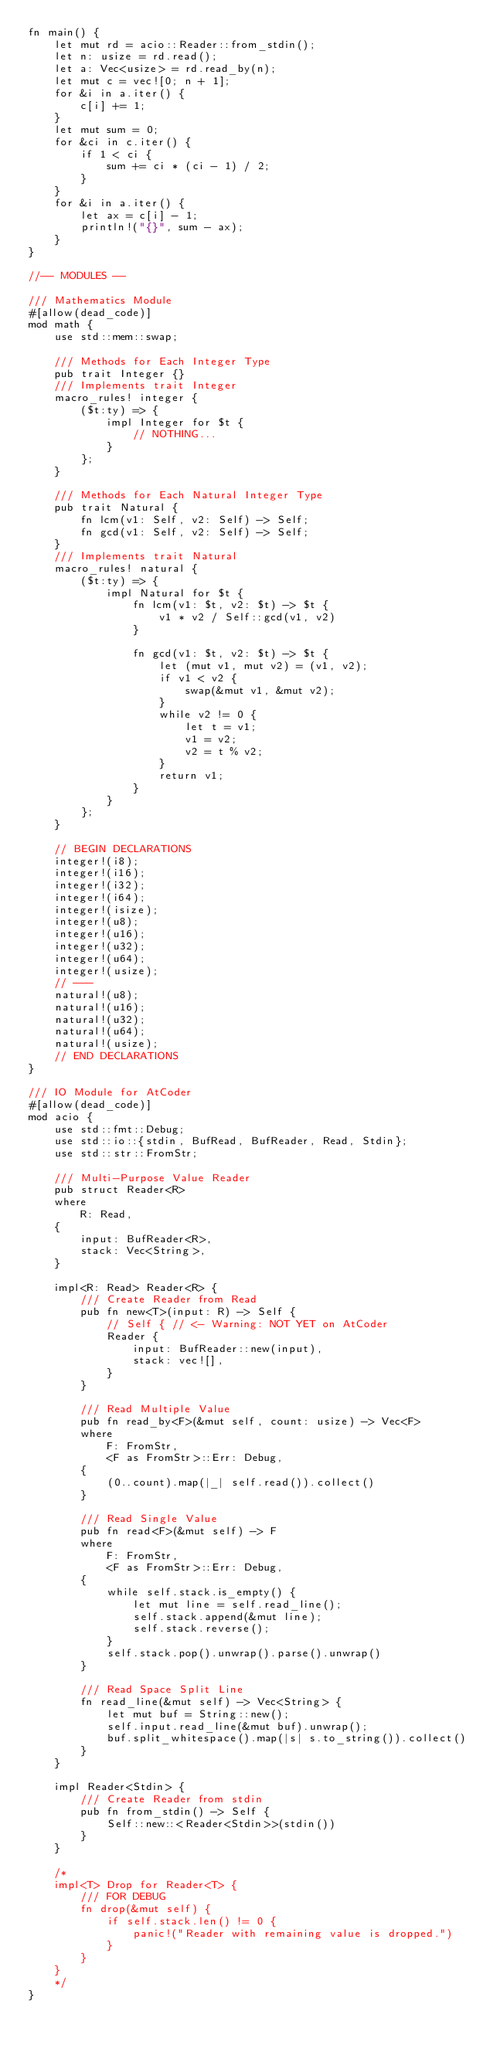<code> <loc_0><loc_0><loc_500><loc_500><_Rust_>fn main() {
    let mut rd = acio::Reader::from_stdin();
    let n: usize = rd.read();
    let a: Vec<usize> = rd.read_by(n);
    let mut c = vec![0; n + 1];
    for &i in a.iter() {
        c[i] += 1;
    }
    let mut sum = 0;
    for &ci in c.iter() {
        if 1 < ci {
            sum += ci * (ci - 1) / 2;
        }
    }
    for &i in a.iter() {
        let ax = c[i] - 1;
        println!("{}", sum - ax);
    }
}

//-- MODULES --

/// Mathematics Module
#[allow(dead_code)]
mod math {
    use std::mem::swap;

    /// Methods for Each Integer Type
    pub trait Integer {}
    /// Implements trait Integer
    macro_rules! integer {
        ($t:ty) => {
            impl Integer for $t {
                // NOTHING...
            }
        };
    }

    /// Methods for Each Natural Integer Type
    pub trait Natural {
        fn lcm(v1: Self, v2: Self) -> Self;
        fn gcd(v1: Self, v2: Self) -> Self;
    }
    /// Implements trait Natural
    macro_rules! natural {
        ($t:ty) => {
            impl Natural for $t {
                fn lcm(v1: $t, v2: $t) -> $t {
                    v1 * v2 / Self::gcd(v1, v2)
                }

                fn gcd(v1: $t, v2: $t) -> $t {
                    let (mut v1, mut v2) = (v1, v2);
                    if v1 < v2 {
                        swap(&mut v1, &mut v2);
                    }
                    while v2 != 0 {
                        let t = v1;
                        v1 = v2;
                        v2 = t % v2;
                    }
                    return v1;
                }
            }
        };
    }

    // BEGIN DECLARATIONS
    integer!(i8);
    integer!(i16);
    integer!(i32);
    integer!(i64);
    integer!(isize);
    integer!(u8);
    integer!(u16);
    integer!(u32);
    integer!(u64);
    integer!(usize);
    // ---
    natural!(u8);
    natural!(u16);
    natural!(u32);
    natural!(u64);
    natural!(usize);
    // END DECLARATIONS
}

/// IO Module for AtCoder
#[allow(dead_code)]
mod acio {
    use std::fmt::Debug;
    use std::io::{stdin, BufRead, BufReader, Read, Stdin};
    use std::str::FromStr;

    /// Multi-Purpose Value Reader
    pub struct Reader<R>
    where
        R: Read,
    {
        input: BufReader<R>,
        stack: Vec<String>,
    }

    impl<R: Read> Reader<R> {
        /// Create Reader from Read
        pub fn new<T>(input: R) -> Self {
            // Self { // <- Warning: NOT YET on AtCoder
            Reader {
                input: BufReader::new(input),
                stack: vec![],
            }
        }

        /// Read Multiple Value
        pub fn read_by<F>(&mut self, count: usize) -> Vec<F>
        where
            F: FromStr,
            <F as FromStr>::Err: Debug,
        {
            (0..count).map(|_| self.read()).collect()
        }

        /// Read Single Value
        pub fn read<F>(&mut self) -> F
        where
            F: FromStr,
            <F as FromStr>::Err: Debug,
        {
            while self.stack.is_empty() {
                let mut line = self.read_line();
                self.stack.append(&mut line);
                self.stack.reverse();
            }
            self.stack.pop().unwrap().parse().unwrap()
        }

        /// Read Space Split Line
        fn read_line(&mut self) -> Vec<String> {
            let mut buf = String::new();
            self.input.read_line(&mut buf).unwrap();
            buf.split_whitespace().map(|s| s.to_string()).collect()
        }
    }

    impl Reader<Stdin> {
        /// Create Reader from stdin
        pub fn from_stdin() -> Self {
            Self::new::<Reader<Stdin>>(stdin())
        }
    }

    /*
    impl<T> Drop for Reader<T> {
        /// FOR DEBUG
        fn drop(&mut self) {
            if self.stack.len() != 0 {
                panic!("Reader with remaining value is dropped.")
            }
        }
    }
    */
}
</code> 